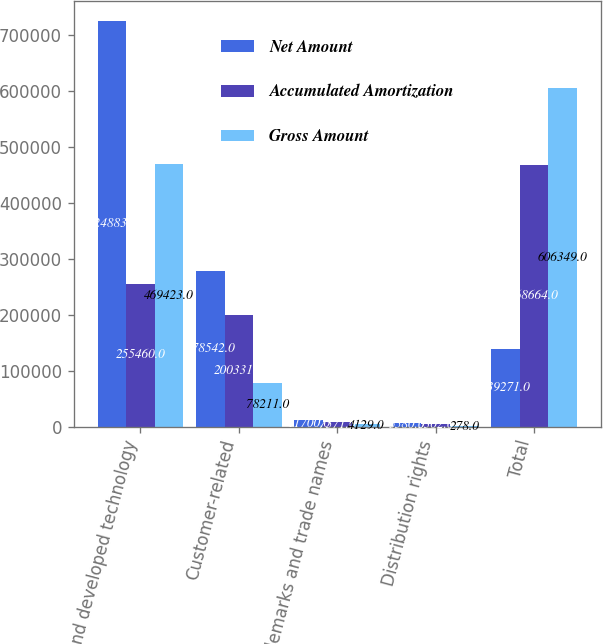Convert chart to OTSL. <chart><loc_0><loc_0><loc_500><loc_500><stacked_bar_chart><ecel><fcel>Core and developed technology<fcel>Customer-related<fcel>Trademarks and trade names<fcel>Distribution rights<fcel>Total<nl><fcel>Net Amount<fcel>724883<fcel>278542<fcel>11700<fcel>5580<fcel>139271<nl><fcel>Accumulated Amortization<fcel>255460<fcel>200331<fcel>7571<fcel>5302<fcel>468664<nl><fcel>Gross Amount<fcel>469423<fcel>78211<fcel>4129<fcel>278<fcel>606349<nl></chart> 